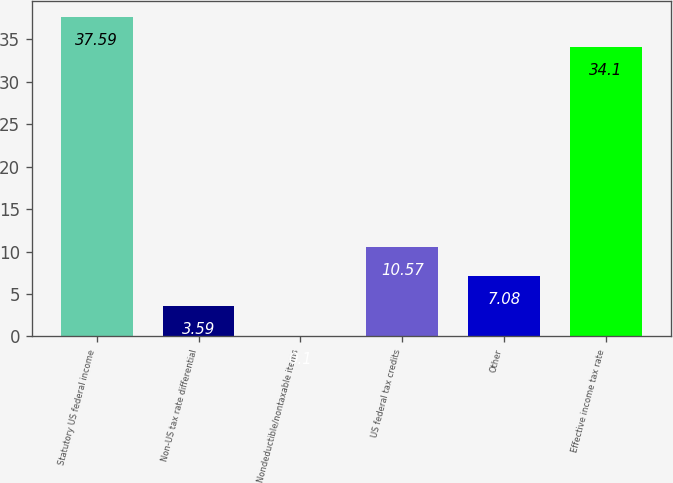<chart> <loc_0><loc_0><loc_500><loc_500><bar_chart><fcel>Statutory US federal income<fcel>Non-US tax rate differential<fcel>Nondeductible/nontaxable items<fcel>US federal tax credits<fcel>Other<fcel>Effective income tax rate<nl><fcel>37.59<fcel>3.59<fcel>0.1<fcel>10.57<fcel>7.08<fcel>34.1<nl></chart> 